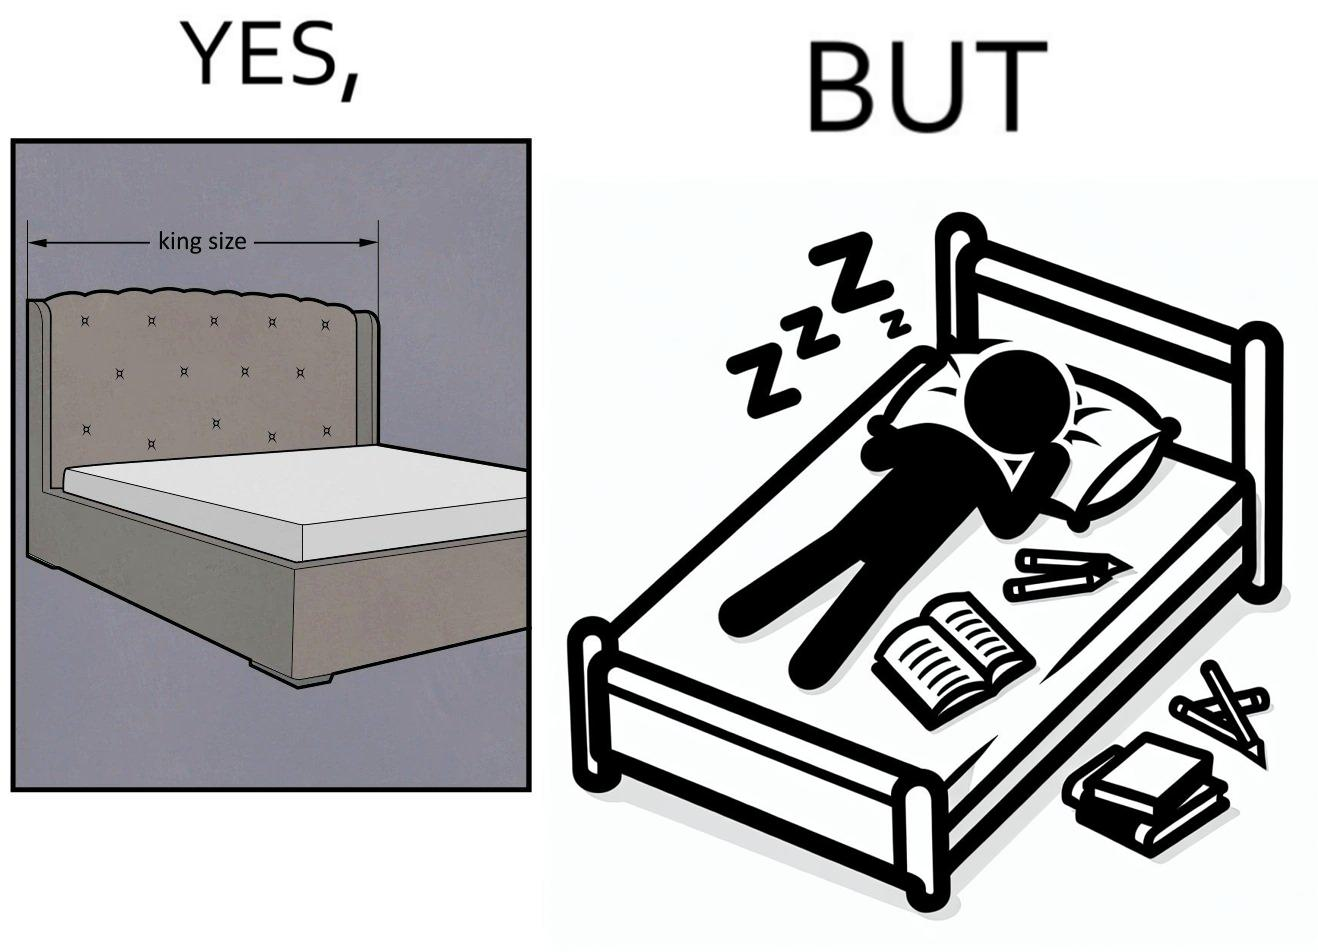Would you classify this image as satirical? Yes, this image is satirical. 